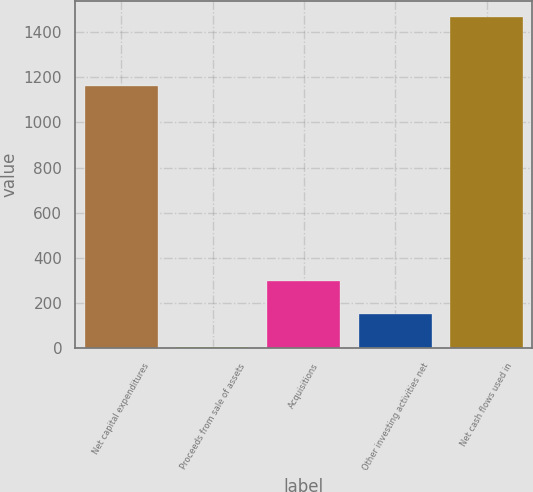Convert chart. <chart><loc_0><loc_0><loc_500><loc_500><bar_chart><fcel>Net capital expenditures<fcel>Proceeds from sale of assets<fcel>Acquisitions<fcel>Other investing activities net<fcel>Net cash flows used in<nl><fcel>1160<fcel>5<fcel>297<fcel>151<fcel>1465<nl></chart> 